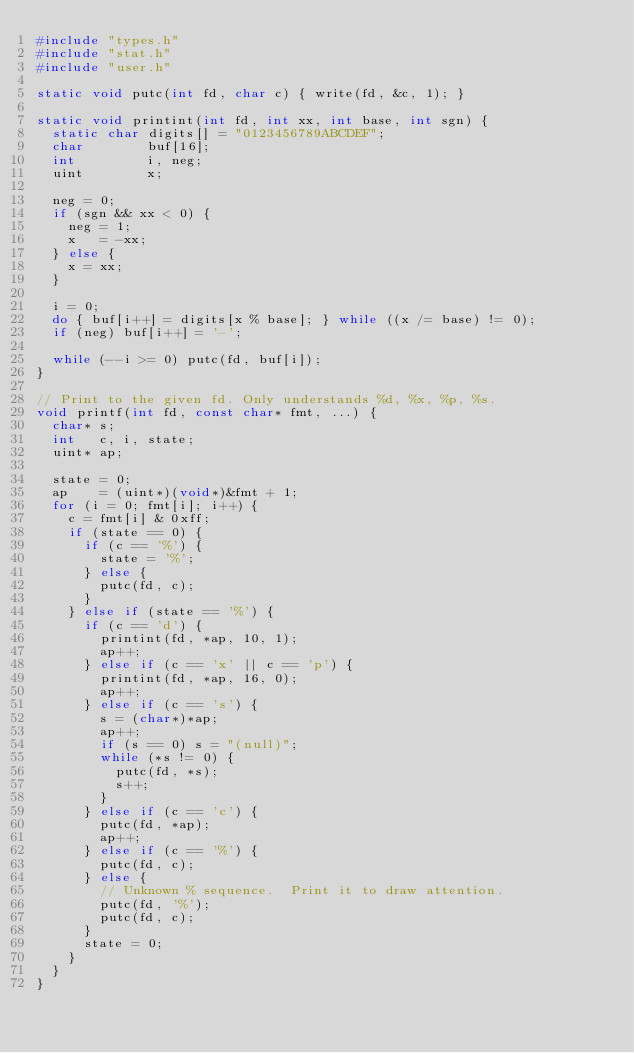Convert code to text. <code><loc_0><loc_0><loc_500><loc_500><_C_>#include "types.h"
#include "stat.h"
#include "user.h"

static void putc(int fd, char c) { write(fd, &c, 1); }

static void printint(int fd, int xx, int base, int sgn) {
  static char digits[] = "0123456789ABCDEF";
  char        buf[16];
  int         i, neg;
  uint        x;

  neg = 0;
  if (sgn && xx < 0) {
    neg = 1;
    x   = -xx;
  } else {
    x = xx;
  }

  i = 0;
  do { buf[i++] = digits[x % base]; } while ((x /= base) != 0);
  if (neg) buf[i++] = '-';

  while (--i >= 0) putc(fd, buf[i]);
}

// Print to the given fd. Only understands %d, %x, %p, %s.
void printf(int fd, const char* fmt, ...) {
  char* s;
  int   c, i, state;
  uint* ap;

  state = 0;
  ap    = (uint*)(void*)&fmt + 1;
  for (i = 0; fmt[i]; i++) {
    c = fmt[i] & 0xff;
    if (state == 0) {
      if (c == '%') {
        state = '%';
      } else {
        putc(fd, c);
      }
    } else if (state == '%') {
      if (c == 'd') {
        printint(fd, *ap, 10, 1);
        ap++;
      } else if (c == 'x' || c == 'p') {
        printint(fd, *ap, 16, 0);
        ap++;
      } else if (c == 's') {
        s = (char*)*ap;
        ap++;
        if (s == 0) s = "(null)";
        while (*s != 0) {
          putc(fd, *s);
          s++;
        }
      } else if (c == 'c') {
        putc(fd, *ap);
        ap++;
      } else if (c == '%') {
        putc(fd, c);
      } else {
        // Unknown % sequence.  Print it to draw attention.
        putc(fd, '%');
        putc(fd, c);
      }
      state = 0;
    }
  }
}
</code> 